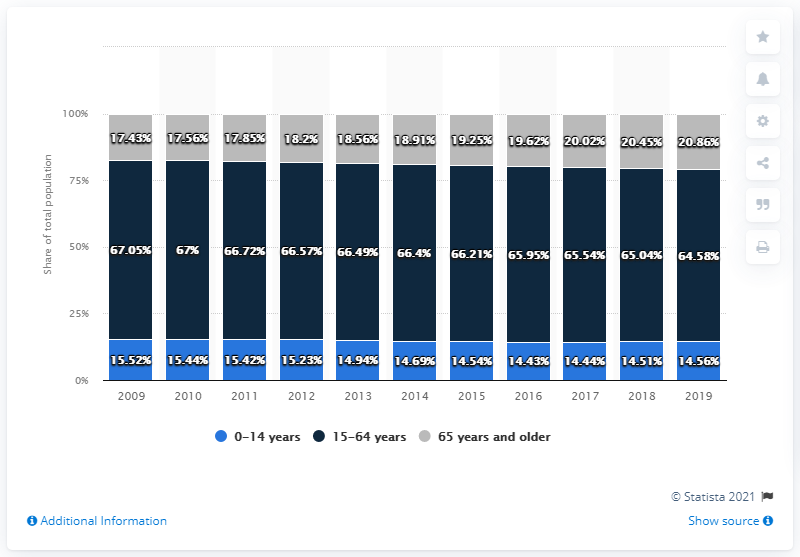Specify some key components in this picture. Grey is typically associated with older age, specifically 65 years and above. In 2016, the age structure with the highest proportion of individuals was between 15 and 64 years old. 